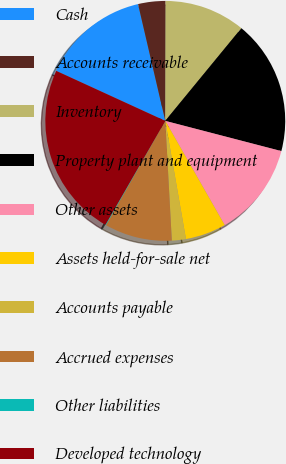<chart> <loc_0><loc_0><loc_500><loc_500><pie_chart><fcel>Cash<fcel>Accounts receivable<fcel>Inventory<fcel>Property plant and equipment<fcel>Other assets<fcel>Assets held-for-sale net<fcel>Accounts payable<fcel>Accrued expenses<fcel>Other liabilities<fcel>Developed technology<nl><fcel>14.51%<fcel>3.69%<fcel>10.9%<fcel>18.11%<fcel>12.7%<fcel>5.49%<fcel>1.89%<fcel>9.1%<fcel>0.09%<fcel>23.52%<nl></chart> 